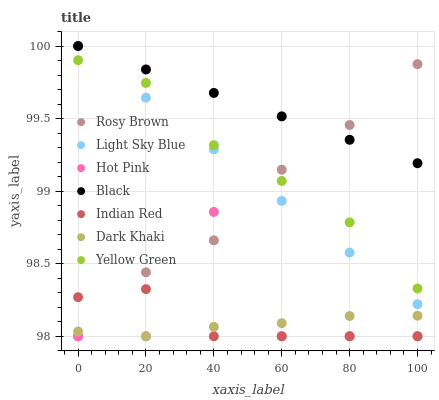Does Dark Khaki have the minimum area under the curve?
Answer yes or no. Yes. Does Black have the maximum area under the curve?
Answer yes or no. Yes. Does Yellow Green have the minimum area under the curve?
Answer yes or no. No. Does Yellow Green have the maximum area under the curve?
Answer yes or no. No. Is Black the smoothest?
Answer yes or no. Yes. Is Hot Pink the roughest?
Answer yes or no. Yes. Is Yellow Green the smoothest?
Answer yes or no. No. Is Yellow Green the roughest?
Answer yes or no. No. Does Hot Pink have the lowest value?
Answer yes or no. Yes. Does Yellow Green have the lowest value?
Answer yes or no. No. Does Black have the highest value?
Answer yes or no. Yes. Does Yellow Green have the highest value?
Answer yes or no. No. Is Dark Khaki less than Black?
Answer yes or no. Yes. Is Light Sky Blue greater than Indian Red?
Answer yes or no. Yes. Does Light Sky Blue intersect Yellow Green?
Answer yes or no. Yes. Is Light Sky Blue less than Yellow Green?
Answer yes or no. No. Is Light Sky Blue greater than Yellow Green?
Answer yes or no. No. Does Dark Khaki intersect Black?
Answer yes or no. No. 